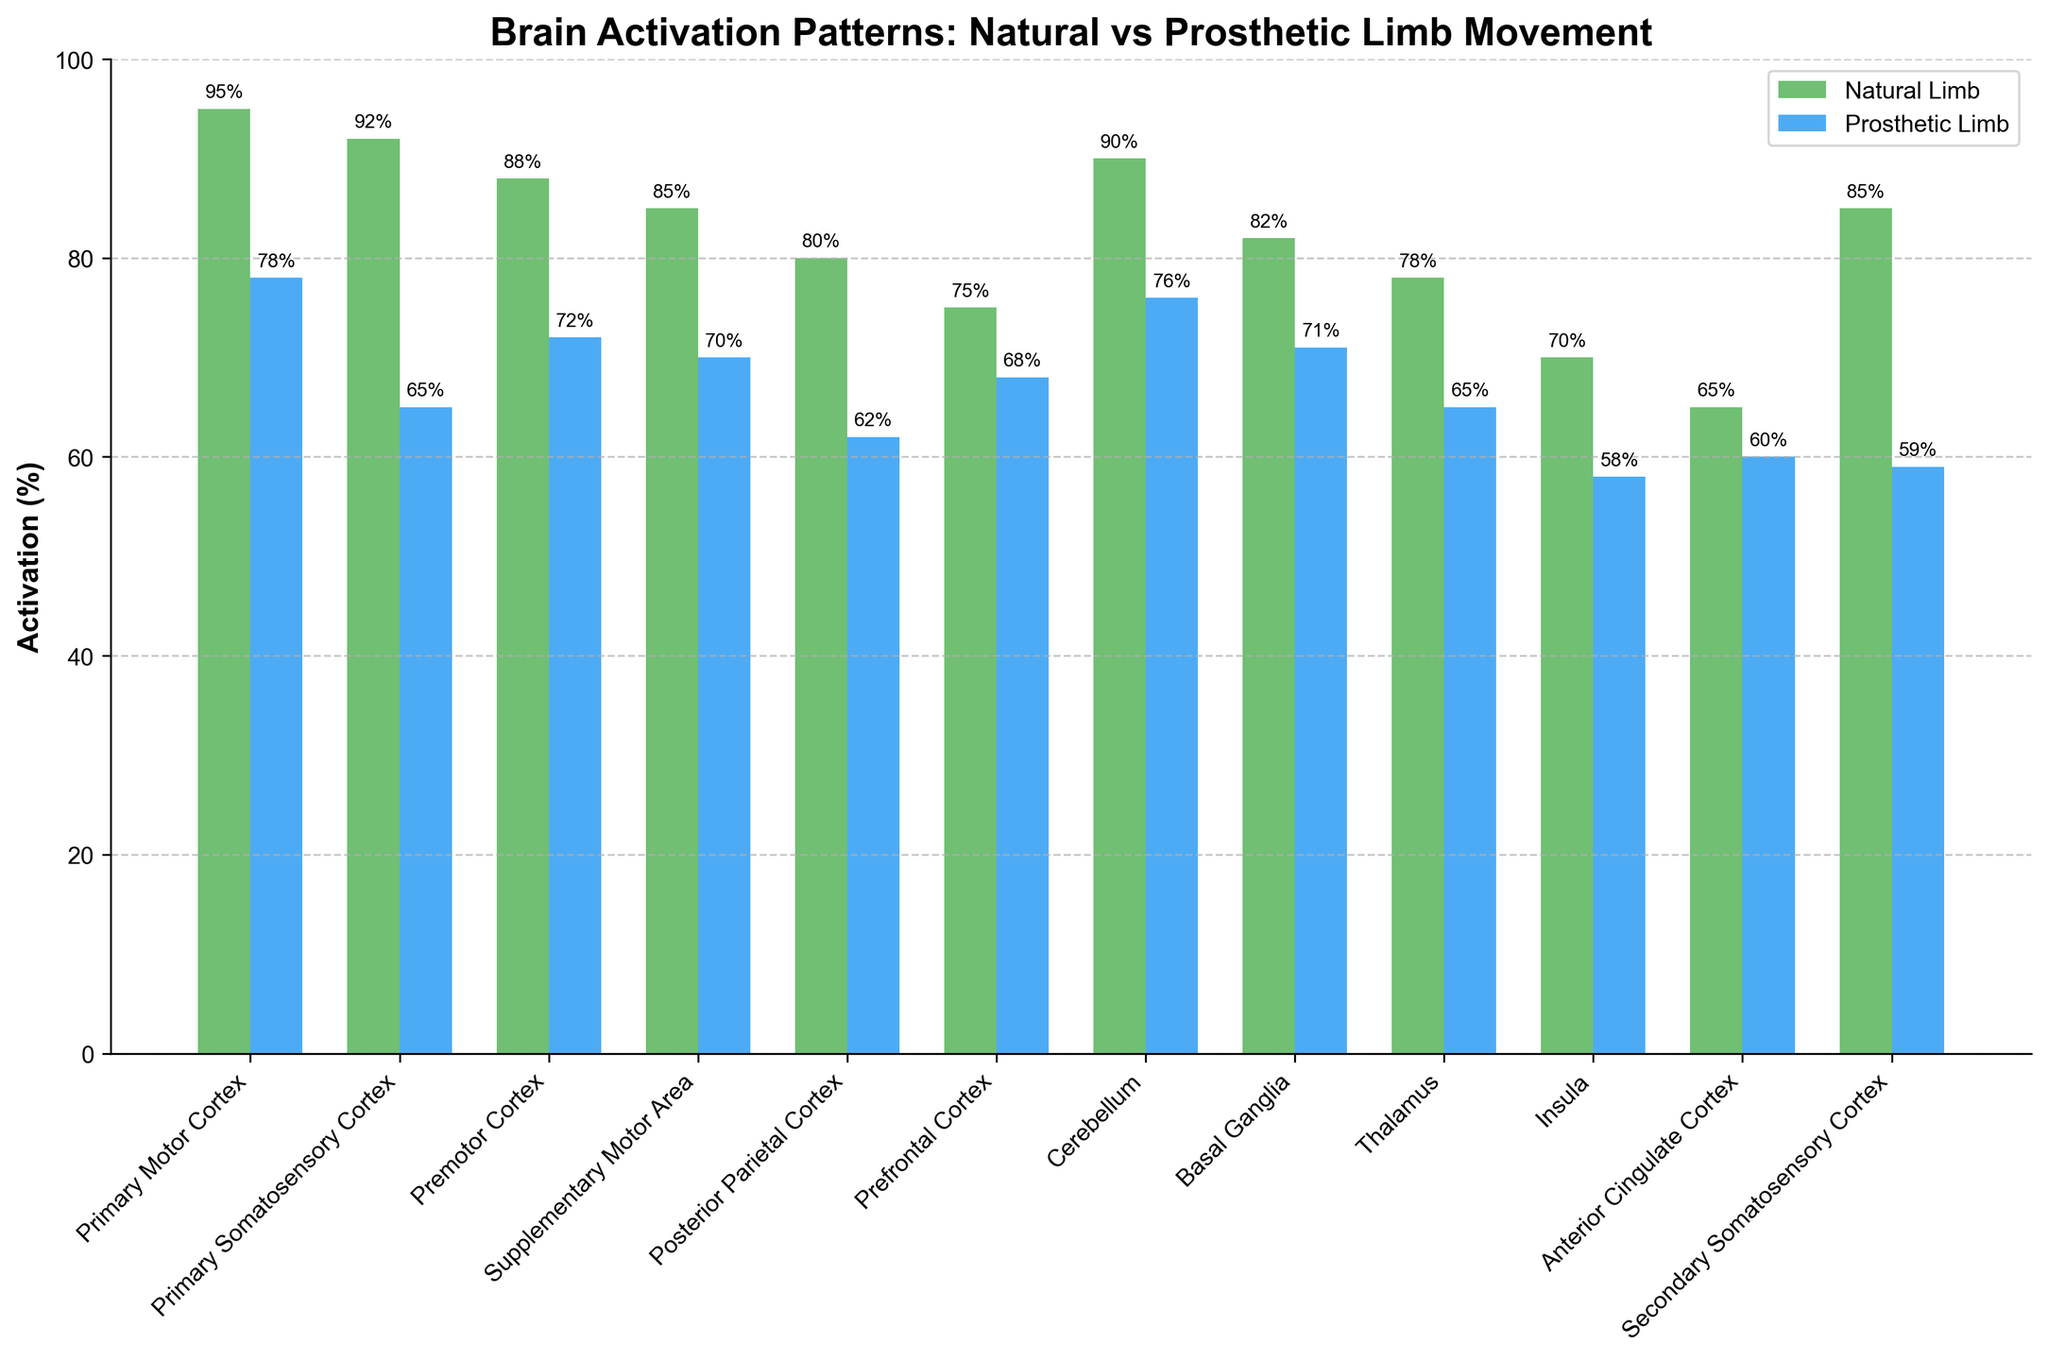Which brain region shows the highest activation in response to natural limb movement? Observe all the bars for natural limb activation (green bars) and identify the tallest one. The Primary Motor Cortex has the highest activation at 95%.
Answer: Primary Motor Cortex Which brain region exhibits the smallest difference in activation between natural and prosthetic limb movements? Look at the difference between the heights of the green and blue bars for each region. The Prefrontal Cortex has the smallest difference, with 75% for natural and 68% for prosthetic, a difference of 7%.
Answer: Prefrontal Cortex What is the average activation percentage for the prosthetic limb movement in the Premotor Cortex and Primary Somatosensory Cortex? Sum the prosthetic activation percentages for the Premotor Cortex and the Primary Somatosensory Cortex (72 + 65) and divide by 2. The average is (72 + 65) / 2 = 68.5%.
Answer: 68.5% Which brain region has a visual correlation where the activation difference between natural and prosthetic limb movements is approximately 20%? Identify bars where the height difference between the green and blue bars is close to 20%. The Primary Somatosensory Cortex has a difference of 27% (92% natural, 65% prosthetic), which is closest to 20%.
Answer: Primary Somatosensory Cortex Is the activation percentage for prosthetic limb movement in the Cerebellum greater than the activation percentage for natural limb movement in the Thalamus? Compare the height of the blue bar for the Cerebellum (76%) with the green bar height for the Thalamus (78%). The prosthetic limb movement in the Cerebellum (76%) is less than the natural limb movement in the Thalamus (78%).
Answer: No How does the activation pattern in the Insula compare to that in the Anterior Cingulate Cortex for prosthetic limb movements? Compare the heights of the blue bars for the Insula (58%) and the Anterior Cingulate Cortex (60%). The Insula has a lower activation (58%) compared to the Anterior Cingulate Cortex (60%).
Answer: The Insula has lower activation What is the combined activation percentage for natural limb movement in the Primary Motor Cortex and the Basal Ganglia? Add the natural limb activation percentages for the Primary Motor Cortex (95%) and the Basal Ganglia (82%). The combined activation percentage is 95% + 82% = 177%.
Answer: 177% Which brain region shows greater activation for prosthetic limb movement, the Thalamus or the Secondary Somatosensory Cortex? Compare the heights of the blue bars for the Thalamus (65%) and the Secondary Somatosensory Cortex (59%). The Thalamus has greater activation (65%).
Answer: Thalamus Identify the brain region with the visually smallest natural limb activation percentage. Observe all the green bars and identify the shortest one. The Anterior Cingulate Cortex has the smallest natural limb activation at 65%.
Answer: Anterior Cingulate Cortex 